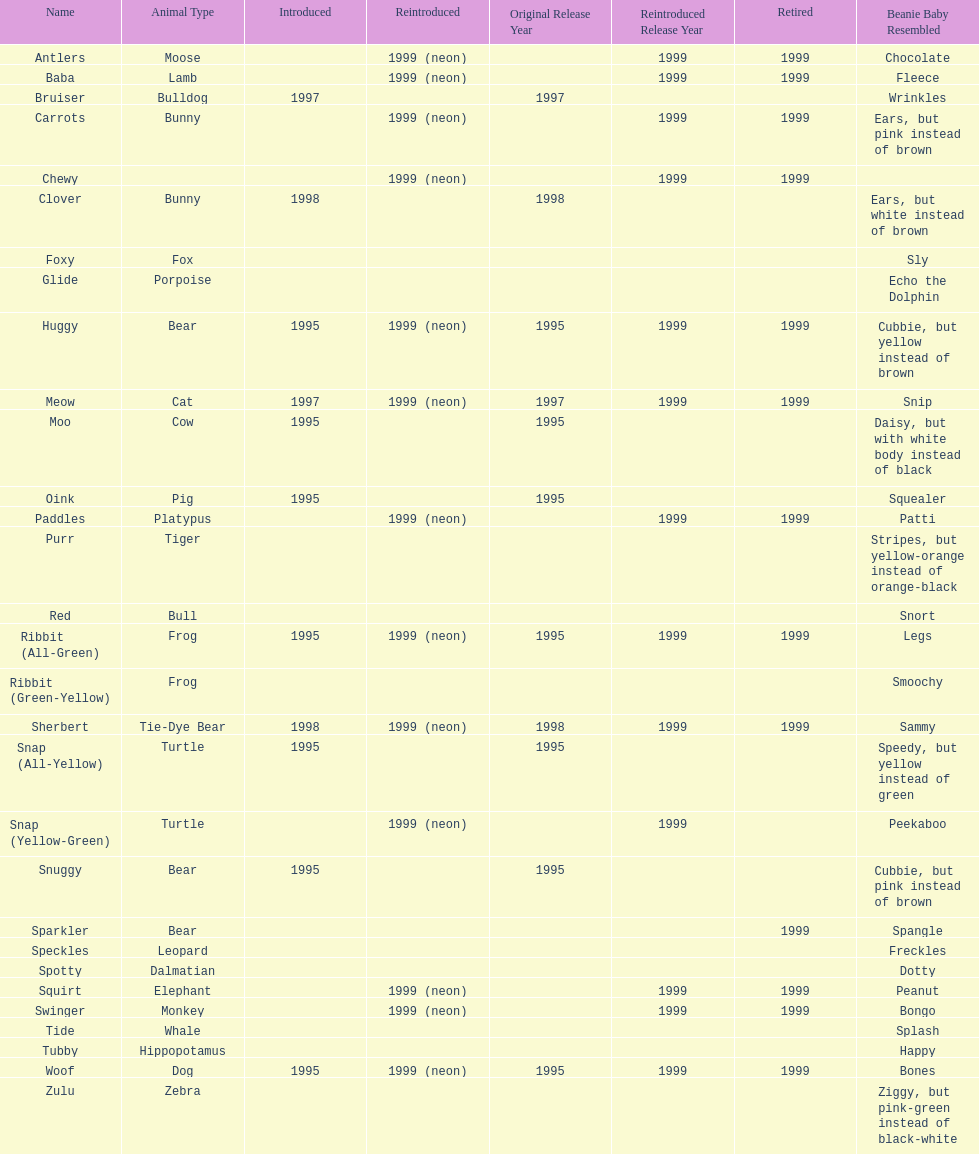How long was woof the dog sold before it was retired? 4 years. Write the full table. {'header': ['Name', 'Animal Type', 'Introduced', 'Reintroduced', 'Original Release Year', 'Reintroduced Release Year', 'Retired', 'Beanie Baby Resembled'], 'rows': [['Antlers', 'Moose', '', '1999 (neon)', '', '1999', '1999', 'Chocolate'], ['Baba', 'Lamb', '', '1999 (neon)', '', '1999', '1999', 'Fleece'], ['Bruiser', 'Bulldog', '1997', '', '1997', '', '', 'Wrinkles'], ['Carrots', 'Bunny', '', '1999 (neon)', '', '1999', '1999', 'Ears, but pink instead of brown'], ['Chewy', '', '', '1999 (neon)', '', '1999', '1999', ''], ['Clover', 'Bunny', '1998', '', '1998', '', '', 'Ears, but white instead of brown'], ['Foxy', 'Fox', '', '', '', '', '', 'Sly'], ['Glide', 'Porpoise', '', '', '', '', '', 'Echo the Dolphin'], ['Huggy', 'Bear', '1995', '1999 (neon)', '1995', '1999', '1999', 'Cubbie, but yellow instead of brown'], ['Meow', 'Cat', '1997', '1999 (neon)', '1997', '1999', '1999', 'Snip'], ['Moo', 'Cow', '1995', '', '1995', '', '', 'Daisy, but with white body instead of black'], ['Oink', 'Pig', '1995', '', '1995', '', '', 'Squealer'], ['Paddles', 'Platypus', '', '1999 (neon)', '', '1999', '1999', 'Patti'], ['Purr', 'Tiger', '', '', '', '', '', 'Stripes, but yellow-orange instead of orange-black'], ['Red', 'Bull', '', '', '', '', '', 'Snort'], ['Ribbit (All-Green)', 'Frog', '1995', '1999 (neon)', '1995', '1999', '1999', 'Legs'], ['Ribbit (Green-Yellow)', 'Frog', '', '', '', '', '', 'Smoochy'], ['Sherbert', 'Tie-Dye Bear', '1998', '1999 (neon)', '1998', '1999', '1999', 'Sammy'], ['Snap (All-Yellow)', 'Turtle', '1995', '', '1995', '', '', 'Speedy, but yellow instead of green'], ['Snap (Yellow-Green)', 'Turtle', '', '1999 (neon)', '', '1999', '', 'Peekaboo'], ['Snuggy', 'Bear', '1995', '', '1995', '', '', 'Cubbie, but pink instead of brown'], ['Sparkler', 'Bear', '', '', '', '', '1999', 'Spangle'], ['Speckles', 'Leopard', '', '', '', '', '', 'Freckles'], ['Spotty', 'Dalmatian', '', '', '', '', '', 'Dotty'], ['Squirt', 'Elephant', '', '1999 (neon)', '', '1999', '1999', 'Peanut'], ['Swinger', 'Monkey', '', '1999 (neon)', '', '1999', '1999', 'Bongo'], ['Tide', 'Whale', '', '', '', '', '', 'Splash'], ['Tubby', 'Hippopotamus', '', '', '', '', '', 'Happy'], ['Woof', 'Dog', '1995', '1999 (neon)', '1995', '1999', '1999', 'Bones'], ['Zulu', 'Zebra', '', '', '', '', '', 'Ziggy, but pink-green instead of black-white']]} 